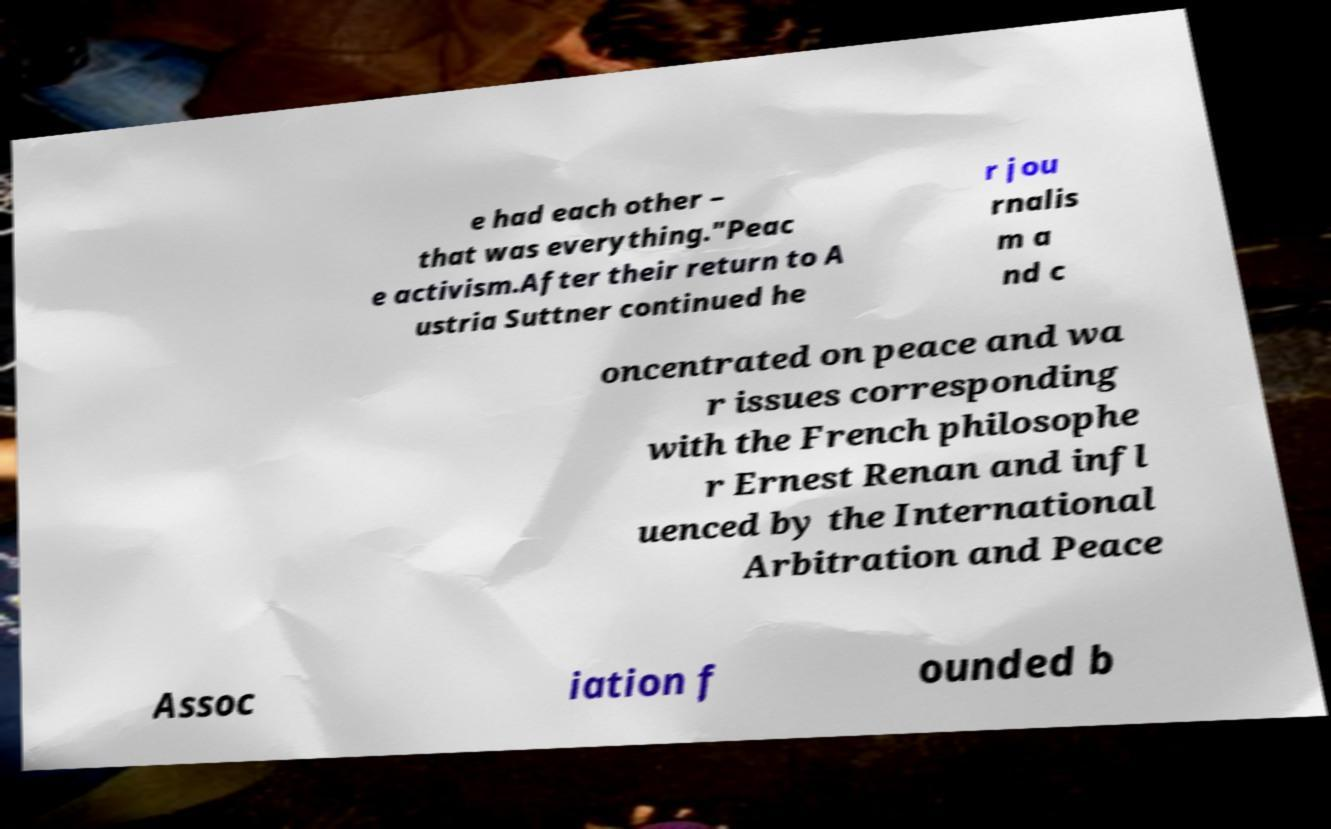For documentation purposes, I need the text within this image transcribed. Could you provide that? e had each other – that was everything."Peac e activism.After their return to A ustria Suttner continued he r jou rnalis m a nd c oncentrated on peace and wa r issues corresponding with the French philosophe r Ernest Renan and infl uenced by the International Arbitration and Peace Assoc iation f ounded b 